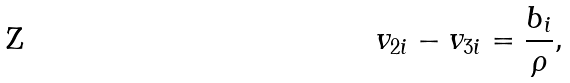<formula> <loc_0><loc_0><loc_500><loc_500>v _ { 2 i } - v _ { 3 i } = \frac { b _ { i } } { \rho } ,</formula> 